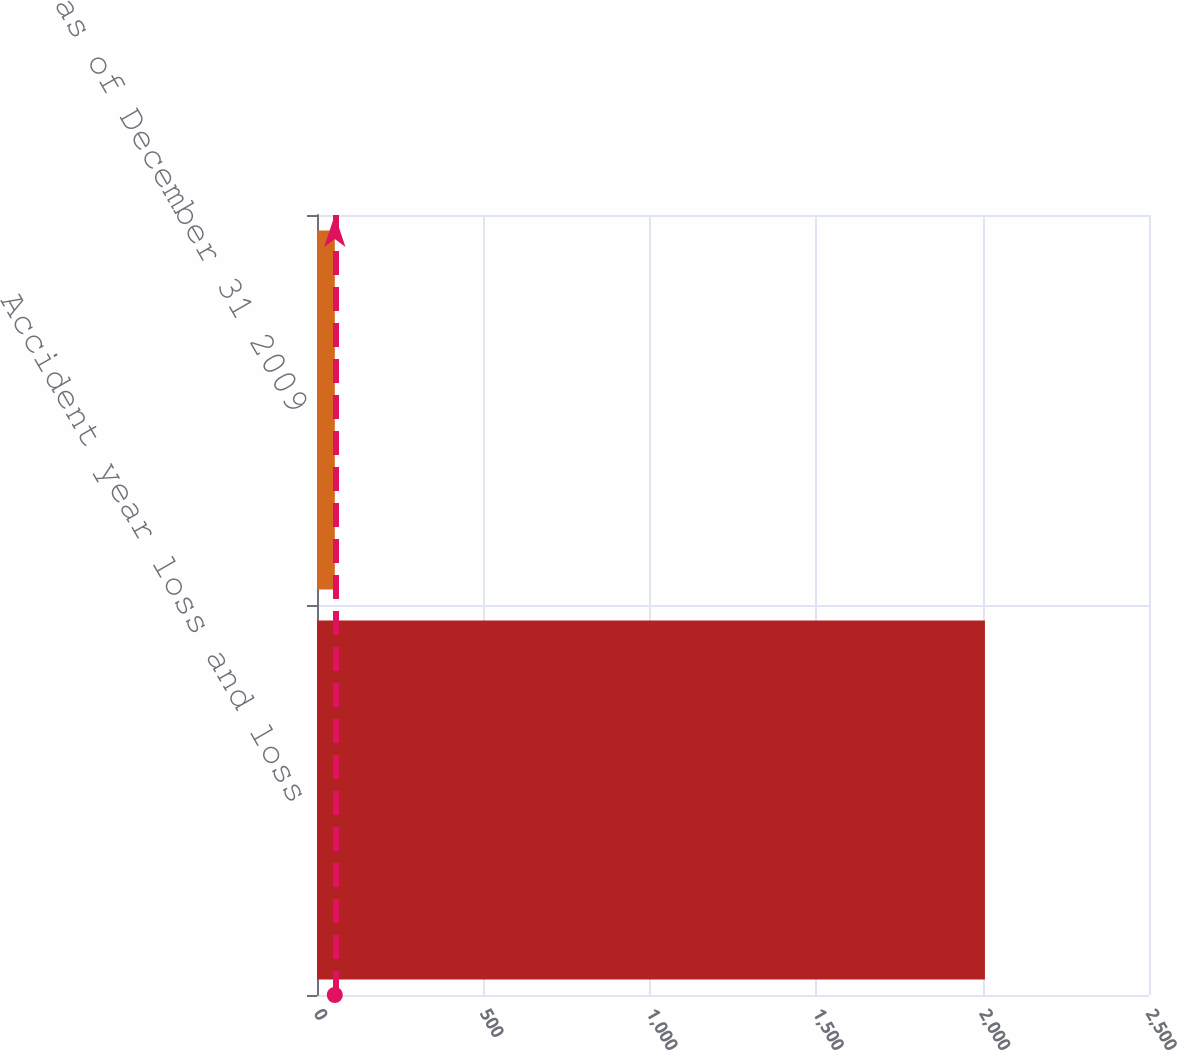Convert chart. <chart><loc_0><loc_0><loc_500><loc_500><bar_chart><fcel>Accident year loss and loss<fcel>as of December 31 2009<nl><fcel>2007<fcel>53.5<nl></chart> 